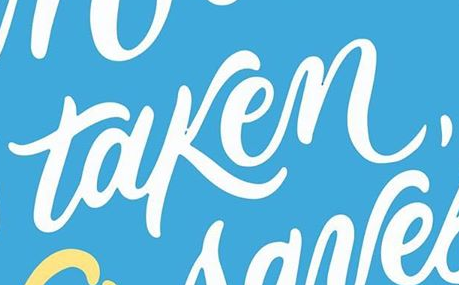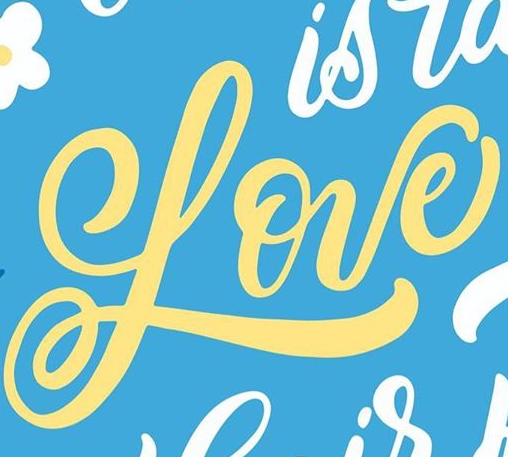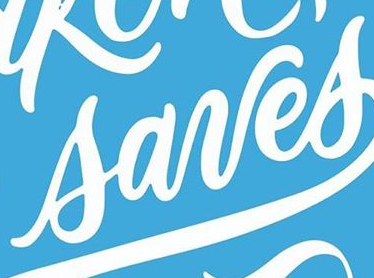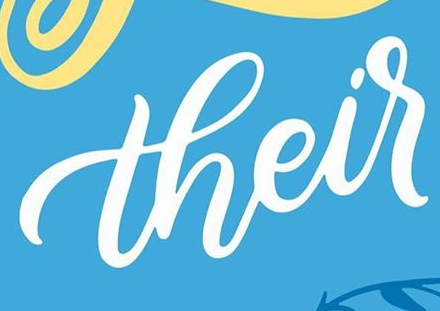What text appears in these images from left to right, separated by a semicolon? taken,; Love; sanes; their 